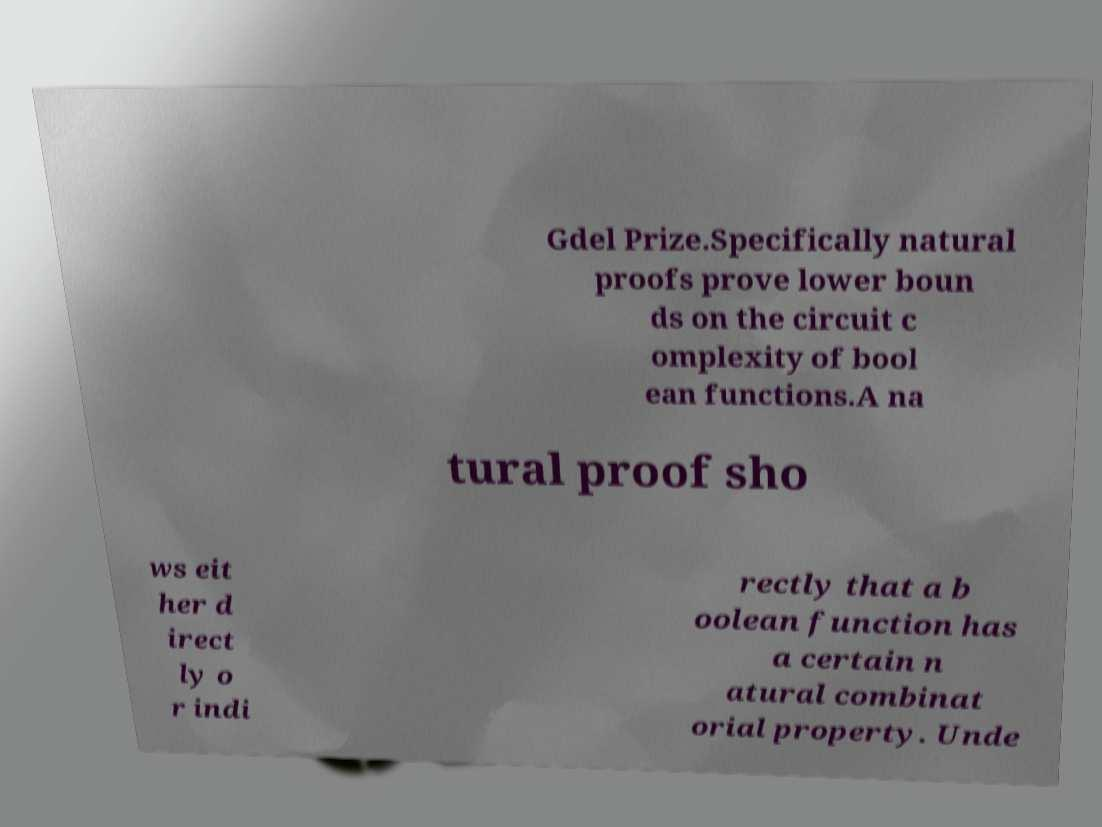Could you extract and type out the text from this image? Gdel Prize.Specifically natural proofs prove lower boun ds on the circuit c omplexity of bool ean functions.A na tural proof sho ws eit her d irect ly o r indi rectly that a b oolean function has a certain n atural combinat orial property. Unde 